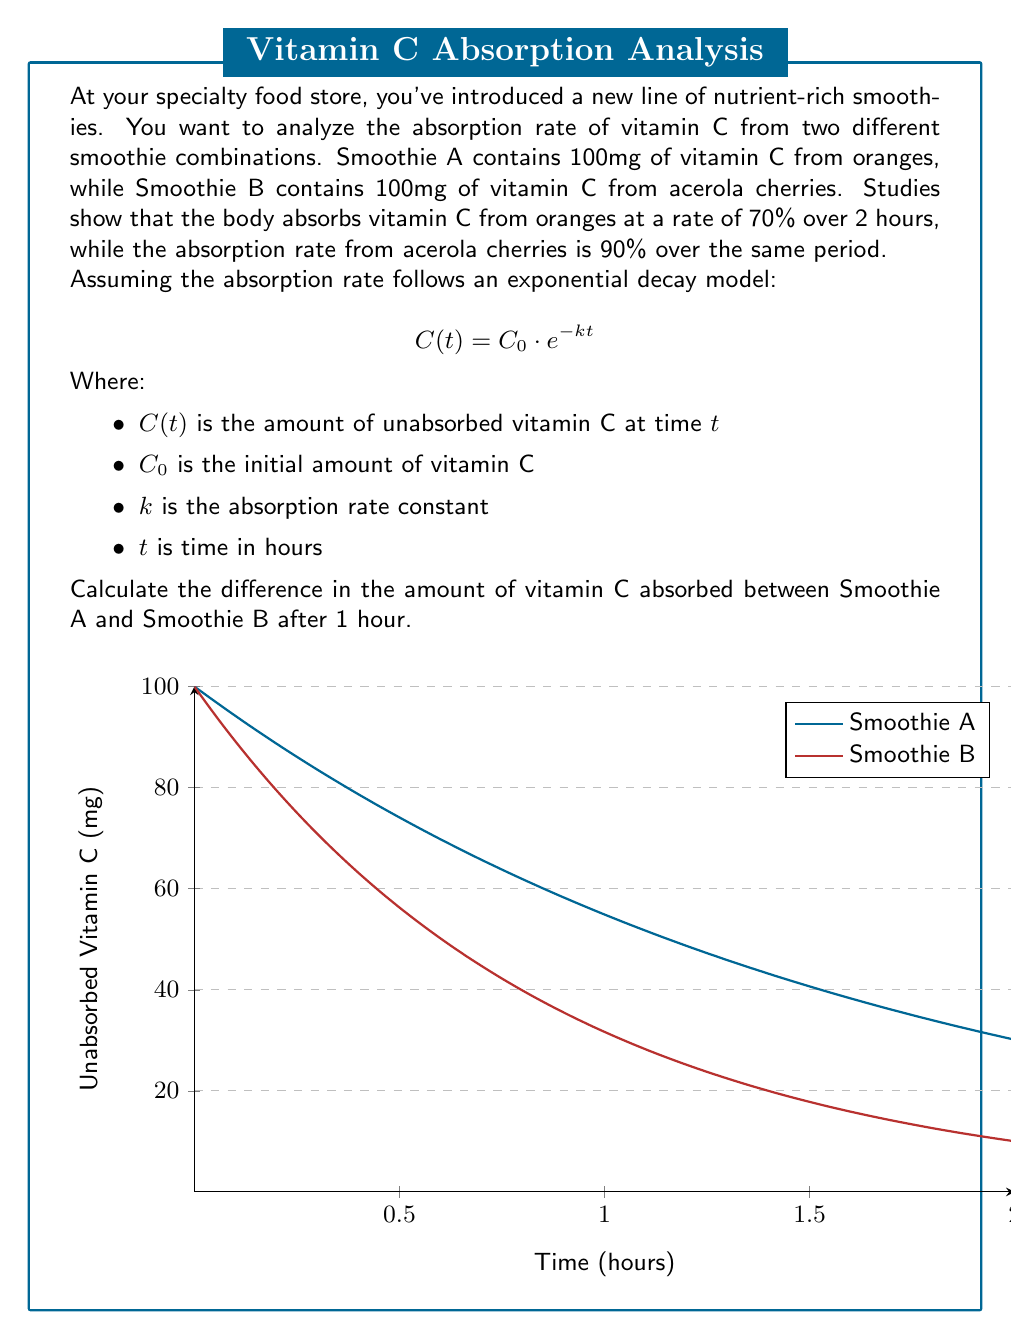Provide a solution to this math problem. To solve this problem, we need to follow these steps:

1. Calculate the absorption rate constant (k) for each smoothie:
   For Smoothie A: $70\% = 1 - e^{-2k}$, solve for $k$
   For Smoothie B: $90\% = 1 - e^{-2k}$, solve for $k$

2. Use the absorption rate constant to calculate the amount of unabsorbed vitamin C after 1 hour for each smoothie.

3. Subtract the unabsorbed amount from the initial amount to find the absorbed amount.

4. Calculate the difference between the absorbed amounts.

Step 1: Calculate k for each smoothie
For Smoothie A:
$$0.70 = 1 - e^{-2k}$$
$$e^{-2k} = 0.30$$
$$-2k = \ln(0.30)$$
$$k = -\frac{\ln(0.30)}{2} \approx 0.6$$

For Smoothie B:
$$0.90 = 1 - e^{-2k}$$
$$e^{-2k} = 0.10$$
$$-2k = \ln(0.10)$$
$$k = -\frac{\ln(0.10)}{2} \approx 1.15$$

Step 2: Calculate unabsorbed vitamin C after 1 hour
For Smoothie A: $C(1) = 100 \cdot e^{-0.6 \cdot 1} \approx 54.88$ mg
For Smoothie B: $C(1) = 100 \cdot e^{-1.15 \cdot 1} \approx 31.69$ mg

Step 3: Calculate absorbed vitamin C after 1 hour
Smoothie A: $100 - 54.88 = 45.12$ mg
Smoothie B: $100 - 31.69 = 68.31$ mg

Step 4: Calculate the difference in absorption
$68.31 - 45.12 = 23.19$ mg

Therefore, after 1 hour, Smoothie B (acerola cherries) has absorbed 23.19 mg more vitamin C than Smoothie A (oranges).
Answer: 23.19 mg 